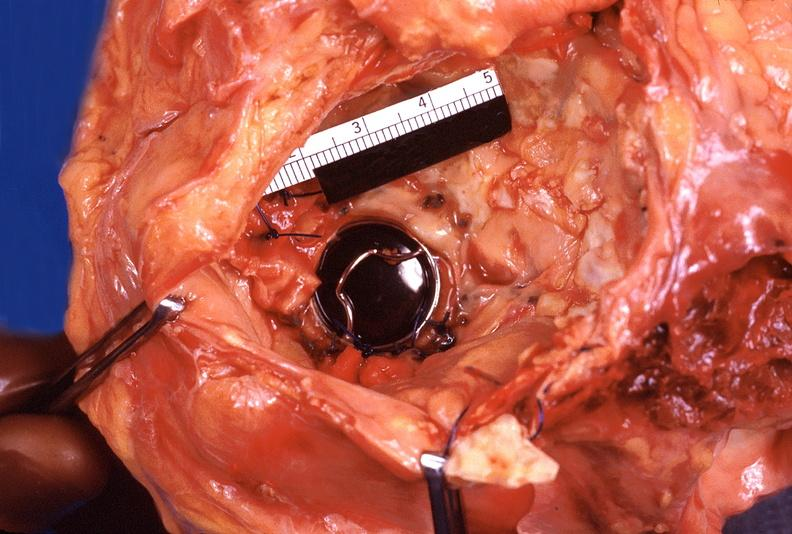where is this?
Answer the question using a single word or phrase. Heart 